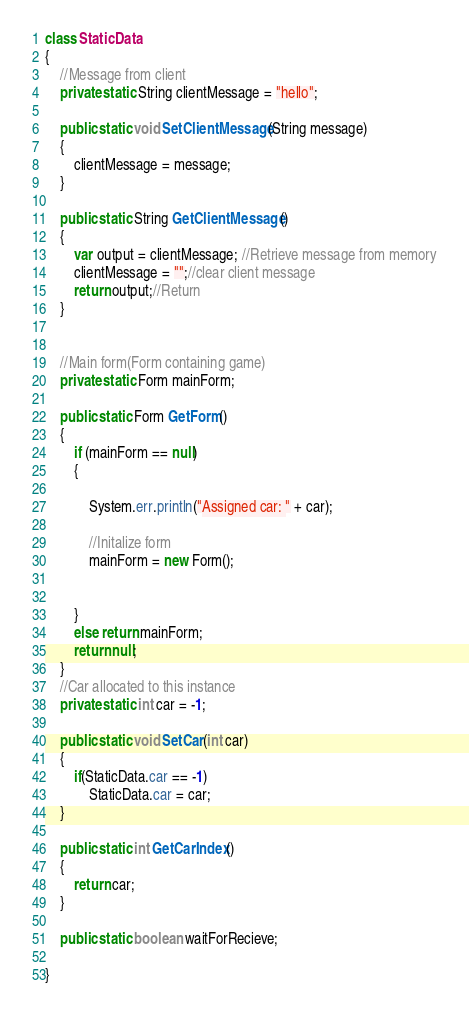Convert code to text. <code><loc_0><loc_0><loc_500><loc_500><_Java_>class StaticData 
{
    //Message from client
    private static String clientMessage = "hello";
    
    public static void SetClientMessage(String message)
    {
        clientMessage = message;
    }
    
    public static String GetClientMessage()
    {
        var output = clientMessage; //Retrieve message from memory
        clientMessage = "";//clear client message
        return output;//Return 
    }
    
    
    //Main form(Form containing game)
    private static Form mainForm;
    
    public static Form GetForm()
    {
        if (mainForm == null)
        {
            
            System.err.println("Assigned car: " + car);

            //Initalize form
            mainForm = new Form();

            
        }
        else return mainForm;
        return null;
    }
    //Car allocated to this instance
    private static int car = -1;
    
    public static void SetCar(int car)
    {
        if(StaticData.car == -1)
            StaticData.car = car;
    }
    
    public static int GetCarIndex()
    {
        return car;
    }
    
    public static boolean waitForRecieve;
    
}</code> 